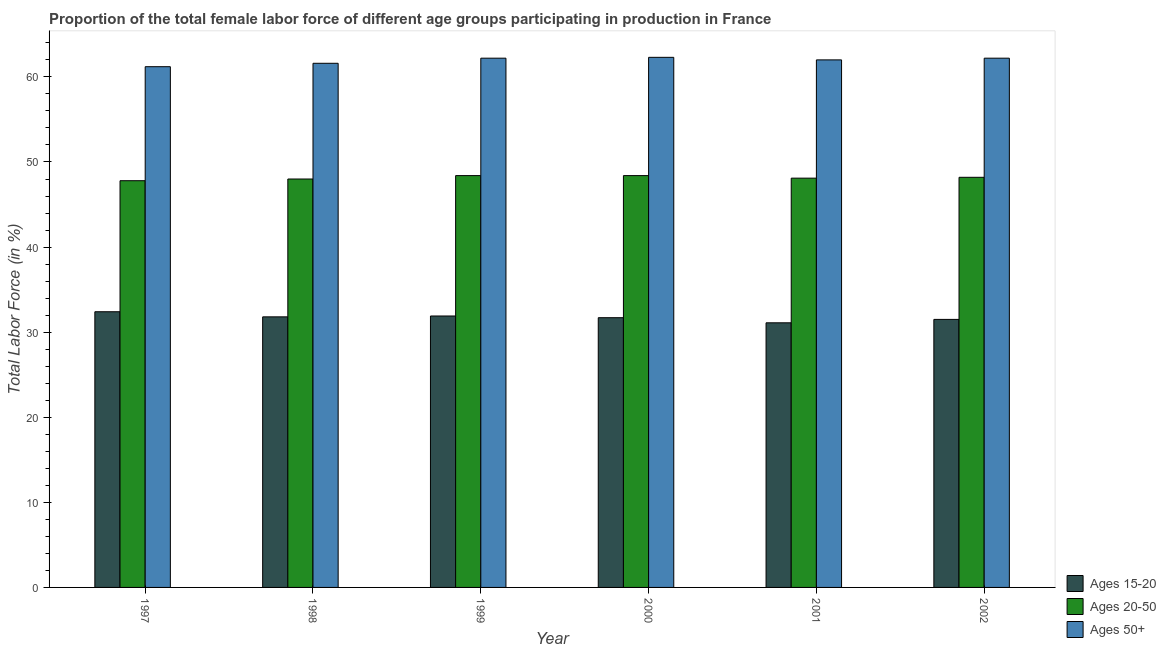Are the number of bars per tick equal to the number of legend labels?
Offer a terse response. Yes. Are the number of bars on each tick of the X-axis equal?
Keep it short and to the point. Yes. What is the percentage of female labor force within the age group 20-50 in 2002?
Give a very brief answer. 48.2. Across all years, what is the maximum percentage of female labor force within the age group 15-20?
Your response must be concise. 32.4. Across all years, what is the minimum percentage of female labor force within the age group 20-50?
Make the answer very short. 47.8. In which year was the percentage of female labor force within the age group 20-50 maximum?
Give a very brief answer. 1999. In which year was the percentage of female labor force above age 50 minimum?
Make the answer very short. 1997. What is the total percentage of female labor force above age 50 in the graph?
Give a very brief answer. 371.5. What is the difference between the percentage of female labor force within the age group 20-50 in 1997 and that in 1998?
Offer a terse response. -0.2. What is the difference between the percentage of female labor force within the age group 15-20 in 2000 and the percentage of female labor force above age 50 in 1998?
Provide a succinct answer. -0.1. What is the average percentage of female labor force within the age group 15-20 per year?
Make the answer very short. 31.73. In the year 2001, what is the difference between the percentage of female labor force within the age group 20-50 and percentage of female labor force above age 50?
Give a very brief answer. 0. What is the ratio of the percentage of female labor force within the age group 15-20 in 1999 to that in 2000?
Offer a very short reply. 1.01. Is the percentage of female labor force above age 50 in 1998 less than that in 2000?
Your answer should be very brief. Yes. What is the difference between the highest and the second highest percentage of female labor force above age 50?
Offer a terse response. 0.1. What is the difference between the highest and the lowest percentage of female labor force within the age group 15-20?
Your answer should be compact. 1.3. Is the sum of the percentage of female labor force above age 50 in 1998 and 2000 greater than the maximum percentage of female labor force within the age group 15-20 across all years?
Provide a short and direct response. Yes. What does the 2nd bar from the left in 2001 represents?
Offer a terse response. Ages 20-50. What does the 2nd bar from the right in 2001 represents?
Keep it short and to the point. Ages 20-50. Is it the case that in every year, the sum of the percentage of female labor force within the age group 15-20 and percentage of female labor force within the age group 20-50 is greater than the percentage of female labor force above age 50?
Provide a short and direct response. Yes. Are all the bars in the graph horizontal?
Make the answer very short. No. What is the difference between two consecutive major ticks on the Y-axis?
Your response must be concise. 10. Are the values on the major ticks of Y-axis written in scientific E-notation?
Provide a short and direct response. No. Does the graph contain any zero values?
Give a very brief answer. No. Does the graph contain grids?
Offer a very short reply. No. How are the legend labels stacked?
Provide a short and direct response. Vertical. What is the title of the graph?
Provide a short and direct response. Proportion of the total female labor force of different age groups participating in production in France. Does "Infant(female)" appear as one of the legend labels in the graph?
Offer a very short reply. No. What is the Total Labor Force (in %) of Ages 15-20 in 1997?
Offer a terse response. 32.4. What is the Total Labor Force (in %) in Ages 20-50 in 1997?
Ensure brevity in your answer.  47.8. What is the Total Labor Force (in %) of Ages 50+ in 1997?
Your answer should be compact. 61.2. What is the Total Labor Force (in %) in Ages 15-20 in 1998?
Give a very brief answer. 31.8. What is the Total Labor Force (in %) of Ages 20-50 in 1998?
Keep it short and to the point. 48. What is the Total Labor Force (in %) of Ages 50+ in 1998?
Your answer should be compact. 61.6. What is the Total Labor Force (in %) in Ages 15-20 in 1999?
Give a very brief answer. 31.9. What is the Total Labor Force (in %) of Ages 20-50 in 1999?
Provide a short and direct response. 48.4. What is the Total Labor Force (in %) of Ages 50+ in 1999?
Offer a very short reply. 62.2. What is the Total Labor Force (in %) in Ages 15-20 in 2000?
Your answer should be very brief. 31.7. What is the Total Labor Force (in %) of Ages 20-50 in 2000?
Give a very brief answer. 48.4. What is the Total Labor Force (in %) in Ages 50+ in 2000?
Offer a terse response. 62.3. What is the Total Labor Force (in %) of Ages 15-20 in 2001?
Offer a terse response. 31.1. What is the Total Labor Force (in %) in Ages 20-50 in 2001?
Your response must be concise. 48.1. What is the Total Labor Force (in %) in Ages 50+ in 2001?
Offer a very short reply. 62. What is the Total Labor Force (in %) in Ages 15-20 in 2002?
Make the answer very short. 31.5. What is the Total Labor Force (in %) of Ages 20-50 in 2002?
Keep it short and to the point. 48.2. What is the Total Labor Force (in %) of Ages 50+ in 2002?
Make the answer very short. 62.2. Across all years, what is the maximum Total Labor Force (in %) in Ages 15-20?
Provide a short and direct response. 32.4. Across all years, what is the maximum Total Labor Force (in %) of Ages 20-50?
Give a very brief answer. 48.4. Across all years, what is the maximum Total Labor Force (in %) in Ages 50+?
Your response must be concise. 62.3. Across all years, what is the minimum Total Labor Force (in %) of Ages 15-20?
Offer a very short reply. 31.1. Across all years, what is the minimum Total Labor Force (in %) in Ages 20-50?
Make the answer very short. 47.8. Across all years, what is the minimum Total Labor Force (in %) in Ages 50+?
Provide a succinct answer. 61.2. What is the total Total Labor Force (in %) of Ages 15-20 in the graph?
Give a very brief answer. 190.4. What is the total Total Labor Force (in %) of Ages 20-50 in the graph?
Your answer should be very brief. 288.9. What is the total Total Labor Force (in %) of Ages 50+ in the graph?
Provide a short and direct response. 371.5. What is the difference between the Total Labor Force (in %) in Ages 20-50 in 1997 and that in 1998?
Ensure brevity in your answer.  -0.2. What is the difference between the Total Labor Force (in %) in Ages 15-20 in 1997 and that in 1999?
Your answer should be very brief. 0.5. What is the difference between the Total Labor Force (in %) of Ages 20-50 in 1997 and that in 1999?
Make the answer very short. -0.6. What is the difference between the Total Labor Force (in %) of Ages 15-20 in 1997 and that in 2000?
Provide a short and direct response. 0.7. What is the difference between the Total Labor Force (in %) in Ages 50+ in 1997 and that in 2000?
Give a very brief answer. -1.1. What is the difference between the Total Labor Force (in %) in Ages 50+ in 1997 and that in 2001?
Your answer should be compact. -0.8. What is the difference between the Total Labor Force (in %) in Ages 15-20 in 1997 and that in 2002?
Your answer should be very brief. 0.9. What is the difference between the Total Labor Force (in %) of Ages 15-20 in 1998 and that in 1999?
Provide a short and direct response. -0.1. What is the difference between the Total Labor Force (in %) of Ages 20-50 in 1998 and that in 1999?
Your answer should be very brief. -0.4. What is the difference between the Total Labor Force (in %) of Ages 50+ in 1998 and that in 1999?
Keep it short and to the point. -0.6. What is the difference between the Total Labor Force (in %) of Ages 15-20 in 1998 and that in 2000?
Make the answer very short. 0.1. What is the difference between the Total Labor Force (in %) in Ages 15-20 in 1998 and that in 2001?
Provide a short and direct response. 0.7. What is the difference between the Total Labor Force (in %) of Ages 15-20 in 1998 and that in 2002?
Provide a short and direct response. 0.3. What is the difference between the Total Labor Force (in %) of Ages 20-50 in 1998 and that in 2002?
Make the answer very short. -0.2. What is the difference between the Total Labor Force (in %) of Ages 50+ in 1998 and that in 2002?
Your response must be concise. -0.6. What is the difference between the Total Labor Force (in %) in Ages 20-50 in 1999 and that in 2000?
Make the answer very short. 0. What is the difference between the Total Labor Force (in %) of Ages 50+ in 1999 and that in 2000?
Ensure brevity in your answer.  -0.1. What is the difference between the Total Labor Force (in %) of Ages 20-50 in 1999 and that in 2001?
Give a very brief answer. 0.3. What is the difference between the Total Labor Force (in %) of Ages 50+ in 1999 and that in 2001?
Ensure brevity in your answer.  0.2. What is the difference between the Total Labor Force (in %) of Ages 50+ in 1999 and that in 2002?
Your answer should be compact. 0. What is the difference between the Total Labor Force (in %) of Ages 15-20 in 2000 and that in 2001?
Give a very brief answer. 0.6. What is the difference between the Total Labor Force (in %) in Ages 15-20 in 2000 and that in 2002?
Give a very brief answer. 0.2. What is the difference between the Total Labor Force (in %) in Ages 20-50 in 2001 and that in 2002?
Make the answer very short. -0.1. What is the difference between the Total Labor Force (in %) in Ages 15-20 in 1997 and the Total Labor Force (in %) in Ages 20-50 in 1998?
Your answer should be very brief. -15.6. What is the difference between the Total Labor Force (in %) in Ages 15-20 in 1997 and the Total Labor Force (in %) in Ages 50+ in 1998?
Give a very brief answer. -29.2. What is the difference between the Total Labor Force (in %) of Ages 20-50 in 1997 and the Total Labor Force (in %) of Ages 50+ in 1998?
Provide a short and direct response. -13.8. What is the difference between the Total Labor Force (in %) in Ages 15-20 in 1997 and the Total Labor Force (in %) in Ages 50+ in 1999?
Offer a terse response. -29.8. What is the difference between the Total Labor Force (in %) of Ages 20-50 in 1997 and the Total Labor Force (in %) of Ages 50+ in 1999?
Provide a succinct answer. -14.4. What is the difference between the Total Labor Force (in %) of Ages 15-20 in 1997 and the Total Labor Force (in %) of Ages 50+ in 2000?
Provide a succinct answer. -29.9. What is the difference between the Total Labor Force (in %) of Ages 20-50 in 1997 and the Total Labor Force (in %) of Ages 50+ in 2000?
Give a very brief answer. -14.5. What is the difference between the Total Labor Force (in %) in Ages 15-20 in 1997 and the Total Labor Force (in %) in Ages 20-50 in 2001?
Your answer should be very brief. -15.7. What is the difference between the Total Labor Force (in %) in Ages 15-20 in 1997 and the Total Labor Force (in %) in Ages 50+ in 2001?
Offer a terse response. -29.6. What is the difference between the Total Labor Force (in %) of Ages 20-50 in 1997 and the Total Labor Force (in %) of Ages 50+ in 2001?
Offer a terse response. -14.2. What is the difference between the Total Labor Force (in %) of Ages 15-20 in 1997 and the Total Labor Force (in %) of Ages 20-50 in 2002?
Your answer should be compact. -15.8. What is the difference between the Total Labor Force (in %) of Ages 15-20 in 1997 and the Total Labor Force (in %) of Ages 50+ in 2002?
Offer a terse response. -29.8. What is the difference between the Total Labor Force (in %) of Ages 20-50 in 1997 and the Total Labor Force (in %) of Ages 50+ in 2002?
Provide a succinct answer. -14.4. What is the difference between the Total Labor Force (in %) of Ages 15-20 in 1998 and the Total Labor Force (in %) of Ages 20-50 in 1999?
Your answer should be compact. -16.6. What is the difference between the Total Labor Force (in %) in Ages 15-20 in 1998 and the Total Labor Force (in %) in Ages 50+ in 1999?
Provide a short and direct response. -30.4. What is the difference between the Total Labor Force (in %) in Ages 15-20 in 1998 and the Total Labor Force (in %) in Ages 20-50 in 2000?
Offer a terse response. -16.6. What is the difference between the Total Labor Force (in %) in Ages 15-20 in 1998 and the Total Labor Force (in %) in Ages 50+ in 2000?
Offer a terse response. -30.5. What is the difference between the Total Labor Force (in %) of Ages 20-50 in 1998 and the Total Labor Force (in %) of Ages 50+ in 2000?
Provide a succinct answer. -14.3. What is the difference between the Total Labor Force (in %) in Ages 15-20 in 1998 and the Total Labor Force (in %) in Ages 20-50 in 2001?
Make the answer very short. -16.3. What is the difference between the Total Labor Force (in %) in Ages 15-20 in 1998 and the Total Labor Force (in %) in Ages 50+ in 2001?
Provide a succinct answer. -30.2. What is the difference between the Total Labor Force (in %) in Ages 15-20 in 1998 and the Total Labor Force (in %) in Ages 20-50 in 2002?
Your answer should be very brief. -16.4. What is the difference between the Total Labor Force (in %) in Ages 15-20 in 1998 and the Total Labor Force (in %) in Ages 50+ in 2002?
Provide a short and direct response. -30.4. What is the difference between the Total Labor Force (in %) of Ages 20-50 in 1998 and the Total Labor Force (in %) of Ages 50+ in 2002?
Your answer should be very brief. -14.2. What is the difference between the Total Labor Force (in %) in Ages 15-20 in 1999 and the Total Labor Force (in %) in Ages 20-50 in 2000?
Your answer should be very brief. -16.5. What is the difference between the Total Labor Force (in %) of Ages 15-20 in 1999 and the Total Labor Force (in %) of Ages 50+ in 2000?
Provide a succinct answer. -30.4. What is the difference between the Total Labor Force (in %) of Ages 15-20 in 1999 and the Total Labor Force (in %) of Ages 20-50 in 2001?
Your response must be concise. -16.2. What is the difference between the Total Labor Force (in %) in Ages 15-20 in 1999 and the Total Labor Force (in %) in Ages 50+ in 2001?
Your response must be concise. -30.1. What is the difference between the Total Labor Force (in %) of Ages 15-20 in 1999 and the Total Labor Force (in %) of Ages 20-50 in 2002?
Make the answer very short. -16.3. What is the difference between the Total Labor Force (in %) in Ages 15-20 in 1999 and the Total Labor Force (in %) in Ages 50+ in 2002?
Give a very brief answer. -30.3. What is the difference between the Total Labor Force (in %) of Ages 15-20 in 2000 and the Total Labor Force (in %) of Ages 20-50 in 2001?
Offer a terse response. -16.4. What is the difference between the Total Labor Force (in %) of Ages 15-20 in 2000 and the Total Labor Force (in %) of Ages 50+ in 2001?
Offer a very short reply. -30.3. What is the difference between the Total Labor Force (in %) in Ages 20-50 in 2000 and the Total Labor Force (in %) in Ages 50+ in 2001?
Ensure brevity in your answer.  -13.6. What is the difference between the Total Labor Force (in %) in Ages 15-20 in 2000 and the Total Labor Force (in %) in Ages 20-50 in 2002?
Keep it short and to the point. -16.5. What is the difference between the Total Labor Force (in %) of Ages 15-20 in 2000 and the Total Labor Force (in %) of Ages 50+ in 2002?
Your response must be concise. -30.5. What is the difference between the Total Labor Force (in %) of Ages 20-50 in 2000 and the Total Labor Force (in %) of Ages 50+ in 2002?
Your answer should be very brief. -13.8. What is the difference between the Total Labor Force (in %) in Ages 15-20 in 2001 and the Total Labor Force (in %) in Ages 20-50 in 2002?
Offer a terse response. -17.1. What is the difference between the Total Labor Force (in %) in Ages 15-20 in 2001 and the Total Labor Force (in %) in Ages 50+ in 2002?
Keep it short and to the point. -31.1. What is the difference between the Total Labor Force (in %) of Ages 20-50 in 2001 and the Total Labor Force (in %) of Ages 50+ in 2002?
Offer a terse response. -14.1. What is the average Total Labor Force (in %) in Ages 15-20 per year?
Ensure brevity in your answer.  31.73. What is the average Total Labor Force (in %) of Ages 20-50 per year?
Make the answer very short. 48.15. What is the average Total Labor Force (in %) of Ages 50+ per year?
Your answer should be very brief. 61.92. In the year 1997, what is the difference between the Total Labor Force (in %) in Ages 15-20 and Total Labor Force (in %) in Ages 20-50?
Offer a very short reply. -15.4. In the year 1997, what is the difference between the Total Labor Force (in %) of Ages 15-20 and Total Labor Force (in %) of Ages 50+?
Provide a succinct answer. -28.8. In the year 1997, what is the difference between the Total Labor Force (in %) of Ages 20-50 and Total Labor Force (in %) of Ages 50+?
Ensure brevity in your answer.  -13.4. In the year 1998, what is the difference between the Total Labor Force (in %) in Ages 15-20 and Total Labor Force (in %) in Ages 20-50?
Give a very brief answer. -16.2. In the year 1998, what is the difference between the Total Labor Force (in %) in Ages 15-20 and Total Labor Force (in %) in Ages 50+?
Your answer should be very brief. -29.8. In the year 1999, what is the difference between the Total Labor Force (in %) in Ages 15-20 and Total Labor Force (in %) in Ages 20-50?
Give a very brief answer. -16.5. In the year 1999, what is the difference between the Total Labor Force (in %) in Ages 15-20 and Total Labor Force (in %) in Ages 50+?
Provide a short and direct response. -30.3. In the year 2000, what is the difference between the Total Labor Force (in %) in Ages 15-20 and Total Labor Force (in %) in Ages 20-50?
Your answer should be very brief. -16.7. In the year 2000, what is the difference between the Total Labor Force (in %) in Ages 15-20 and Total Labor Force (in %) in Ages 50+?
Provide a succinct answer. -30.6. In the year 2000, what is the difference between the Total Labor Force (in %) in Ages 20-50 and Total Labor Force (in %) in Ages 50+?
Your response must be concise. -13.9. In the year 2001, what is the difference between the Total Labor Force (in %) in Ages 15-20 and Total Labor Force (in %) in Ages 20-50?
Offer a very short reply. -17. In the year 2001, what is the difference between the Total Labor Force (in %) of Ages 15-20 and Total Labor Force (in %) of Ages 50+?
Give a very brief answer. -30.9. In the year 2001, what is the difference between the Total Labor Force (in %) in Ages 20-50 and Total Labor Force (in %) in Ages 50+?
Offer a terse response. -13.9. In the year 2002, what is the difference between the Total Labor Force (in %) of Ages 15-20 and Total Labor Force (in %) of Ages 20-50?
Give a very brief answer. -16.7. In the year 2002, what is the difference between the Total Labor Force (in %) in Ages 15-20 and Total Labor Force (in %) in Ages 50+?
Your answer should be compact. -30.7. In the year 2002, what is the difference between the Total Labor Force (in %) of Ages 20-50 and Total Labor Force (in %) of Ages 50+?
Your answer should be compact. -14. What is the ratio of the Total Labor Force (in %) of Ages 15-20 in 1997 to that in 1998?
Offer a very short reply. 1.02. What is the ratio of the Total Labor Force (in %) of Ages 20-50 in 1997 to that in 1998?
Ensure brevity in your answer.  1. What is the ratio of the Total Labor Force (in %) of Ages 50+ in 1997 to that in 1998?
Your answer should be very brief. 0.99. What is the ratio of the Total Labor Force (in %) in Ages 15-20 in 1997 to that in 1999?
Your answer should be very brief. 1.02. What is the ratio of the Total Labor Force (in %) of Ages 20-50 in 1997 to that in 1999?
Make the answer very short. 0.99. What is the ratio of the Total Labor Force (in %) of Ages 50+ in 1997 to that in 1999?
Your answer should be very brief. 0.98. What is the ratio of the Total Labor Force (in %) of Ages 15-20 in 1997 to that in 2000?
Your response must be concise. 1.02. What is the ratio of the Total Labor Force (in %) in Ages 20-50 in 1997 to that in 2000?
Ensure brevity in your answer.  0.99. What is the ratio of the Total Labor Force (in %) in Ages 50+ in 1997 to that in 2000?
Give a very brief answer. 0.98. What is the ratio of the Total Labor Force (in %) of Ages 15-20 in 1997 to that in 2001?
Provide a short and direct response. 1.04. What is the ratio of the Total Labor Force (in %) in Ages 20-50 in 1997 to that in 2001?
Provide a short and direct response. 0.99. What is the ratio of the Total Labor Force (in %) of Ages 50+ in 1997 to that in 2001?
Give a very brief answer. 0.99. What is the ratio of the Total Labor Force (in %) in Ages 15-20 in 1997 to that in 2002?
Offer a terse response. 1.03. What is the ratio of the Total Labor Force (in %) of Ages 50+ in 1997 to that in 2002?
Ensure brevity in your answer.  0.98. What is the ratio of the Total Labor Force (in %) in Ages 20-50 in 1998 to that in 1999?
Offer a very short reply. 0.99. What is the ratio of the Total Labor Force (in %) of Ages 50+ in 1998 to that in 1999?
Your answer should be very brief. 0.99. What is the ratio of the Total Labor Force (in %) in Ages 50+ in 1998 to that in 2000?
Provide a short and direct response. 0.99. What is the ratio of the Total Labor Force (in %) in Ages 15-20 in 1998 to that in 2001?
Your response must be concise. 1.02. What is the ratio of the Total Labor Force (in %) of Ages 50+ in 1998 to that in 2001?
Keep it short and to the point. 0.99. What is the ratio of the Total Labor Force (in %) of Ages 15-20 in 1998 to that in 2002?
Ensure brevity in your answer.  1.01. What is the ratio of the Total Labor Force (in %) in Ages 20-50 in 1998 to that in 2002?
Give a very brief answer. 1. What is the ratio of the Total Labor Force (in %) of Ages 50+ in 1998 to that in 2002?
Your answer should be very brief. 0.99. What is the ratio of the Total Labor Force (in %) of Ages 50+ in 1999 to that in 2000?
Offer a terse response. 1. What is the ratio of the Total Labor Force (in %) of Ages 15-20 in 1999 to that in 2001?
Keep it short and to the point. 1.03. What is the ratio of the Total Labor Force (in %) of Ages 50+ in 1999 to that in 2001?
Your answer should be compact. 1. What is the ratio of the Total Labor Force (in %) in Ages 15-20 in 1999 to that in 2002?
Give a very brief answer. 1.01. What is the ratio of the Total Labor Force (in %) in Ages 15-20 in 2000 to that in 2001?
Provide a succinct answer. 1.02. What is the ratio of the Total Labor Force (in %) of Ages 20-50 in 2000 to that in 2002?
Offer a very short reply. 1. What is the ratio of the Total Labor Force (in %) in Ages 15-20 in 2001 to that in 2002?
Your response must be concise. 0.99. What is the ratio of the Total Labor Force (in %) of Ages 20-50 in 2001 to that in 2002?
Give a very brief answer. 1. What is the ratio of the Total Labor Force (in %) in Ages 50+ in 2001 to that in 2002?
Your answer should be compact. 1. What is the difference between the highest and the second highest Total Labor Force (in %) in Ages 15-20?
Make the answer very short. 0.5. What is the difference between the highest and the lowest Total Labor Force (in %) in Ages 20-50?
Offer a terse response. 0.6. 